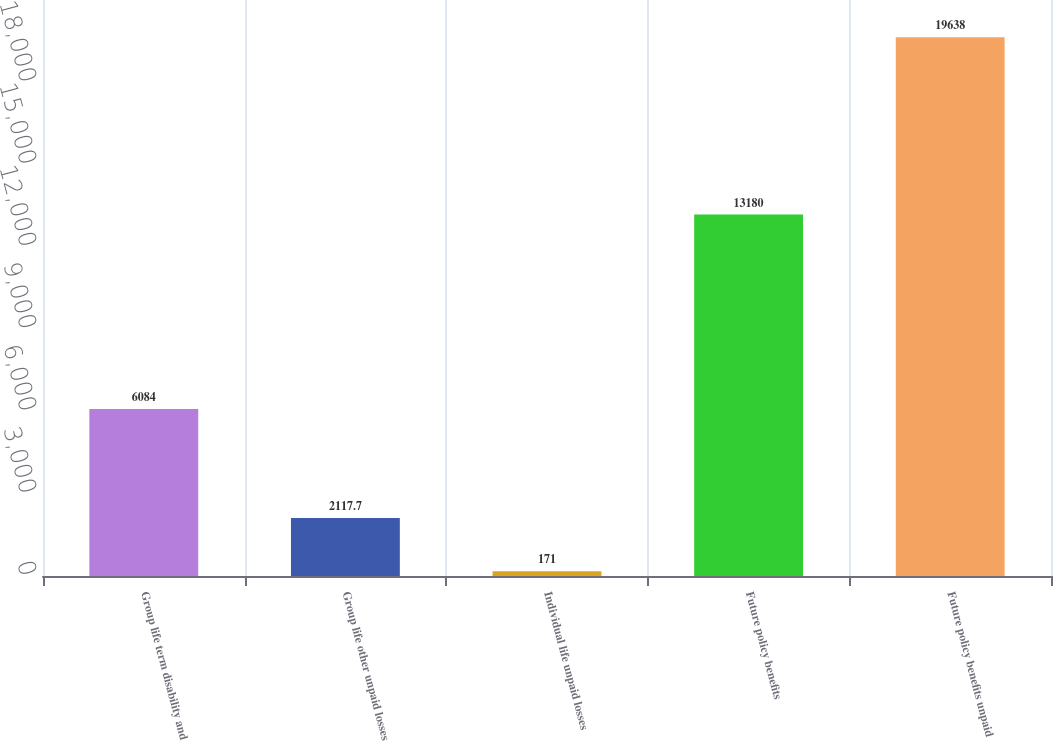Convert chart to OTSL. <chart><loc_0><loc_0><loc_500><loc_500><bar_chart><fcel>Group life term disability and<fcel>Group life other unpaid losses<fcel>Individual life unpaid losses<fcel>Future policy benefits<fcel>Future policy benefits unpaid<nl><fcel>6084<fcel>2117.7<fcel>171<fcel>13180<fcel>19638<nl></chart> 